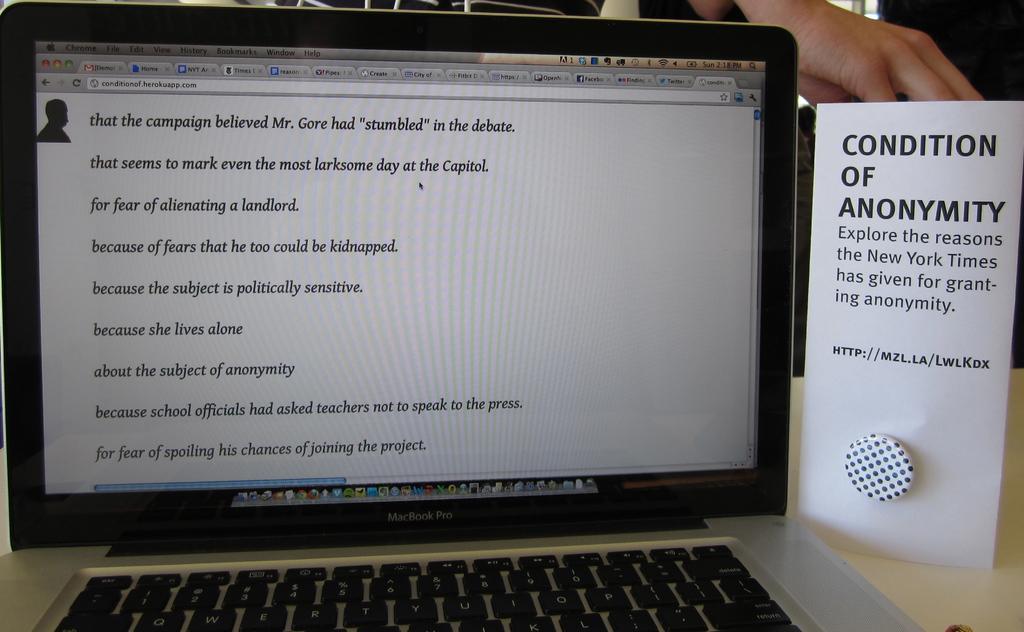How would you summarize this image in a sentence or two? In this image we can see laptop which is of silver and brown color and there is some text which is displaying on the screen, on the right side of the image there is some object which is in white color and in the background of the image we can see some person's hand near the object. 